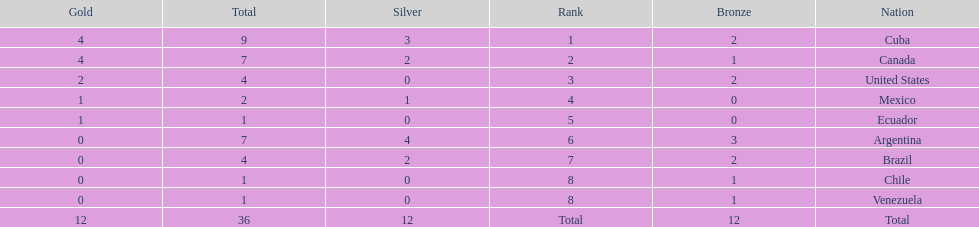I'm looking to parse the entire table for insights. Could you assist me with that? {'header': ['Gold', 'Total', 'Silver', 'Rank', 'Bronze', 'Nation'], 'rows': [['4', '9', '3', '1', '2', 'Cuba'], ['4', '7', '2', '2', '1', 'Canada'], ['2', '4', '0', '3', '2', 'United States'], ['1', '2', '1', '4', '0', 'Mexico'], ['1', '1', '0', '5', '0', 'Ecuador'], ['0', '7', '4', '6', '3', 'Argentina'], ['0', '4', '2', '7', '2', 'Brazil'], ['0', '1', '0', '8', '1', 'Chile'], ['0', '1', '0', '8', '1', 'Venezuela'], ['12', '36', '12', 'Total', '12', 'Total']]} How many total medals were there all together? 36. 